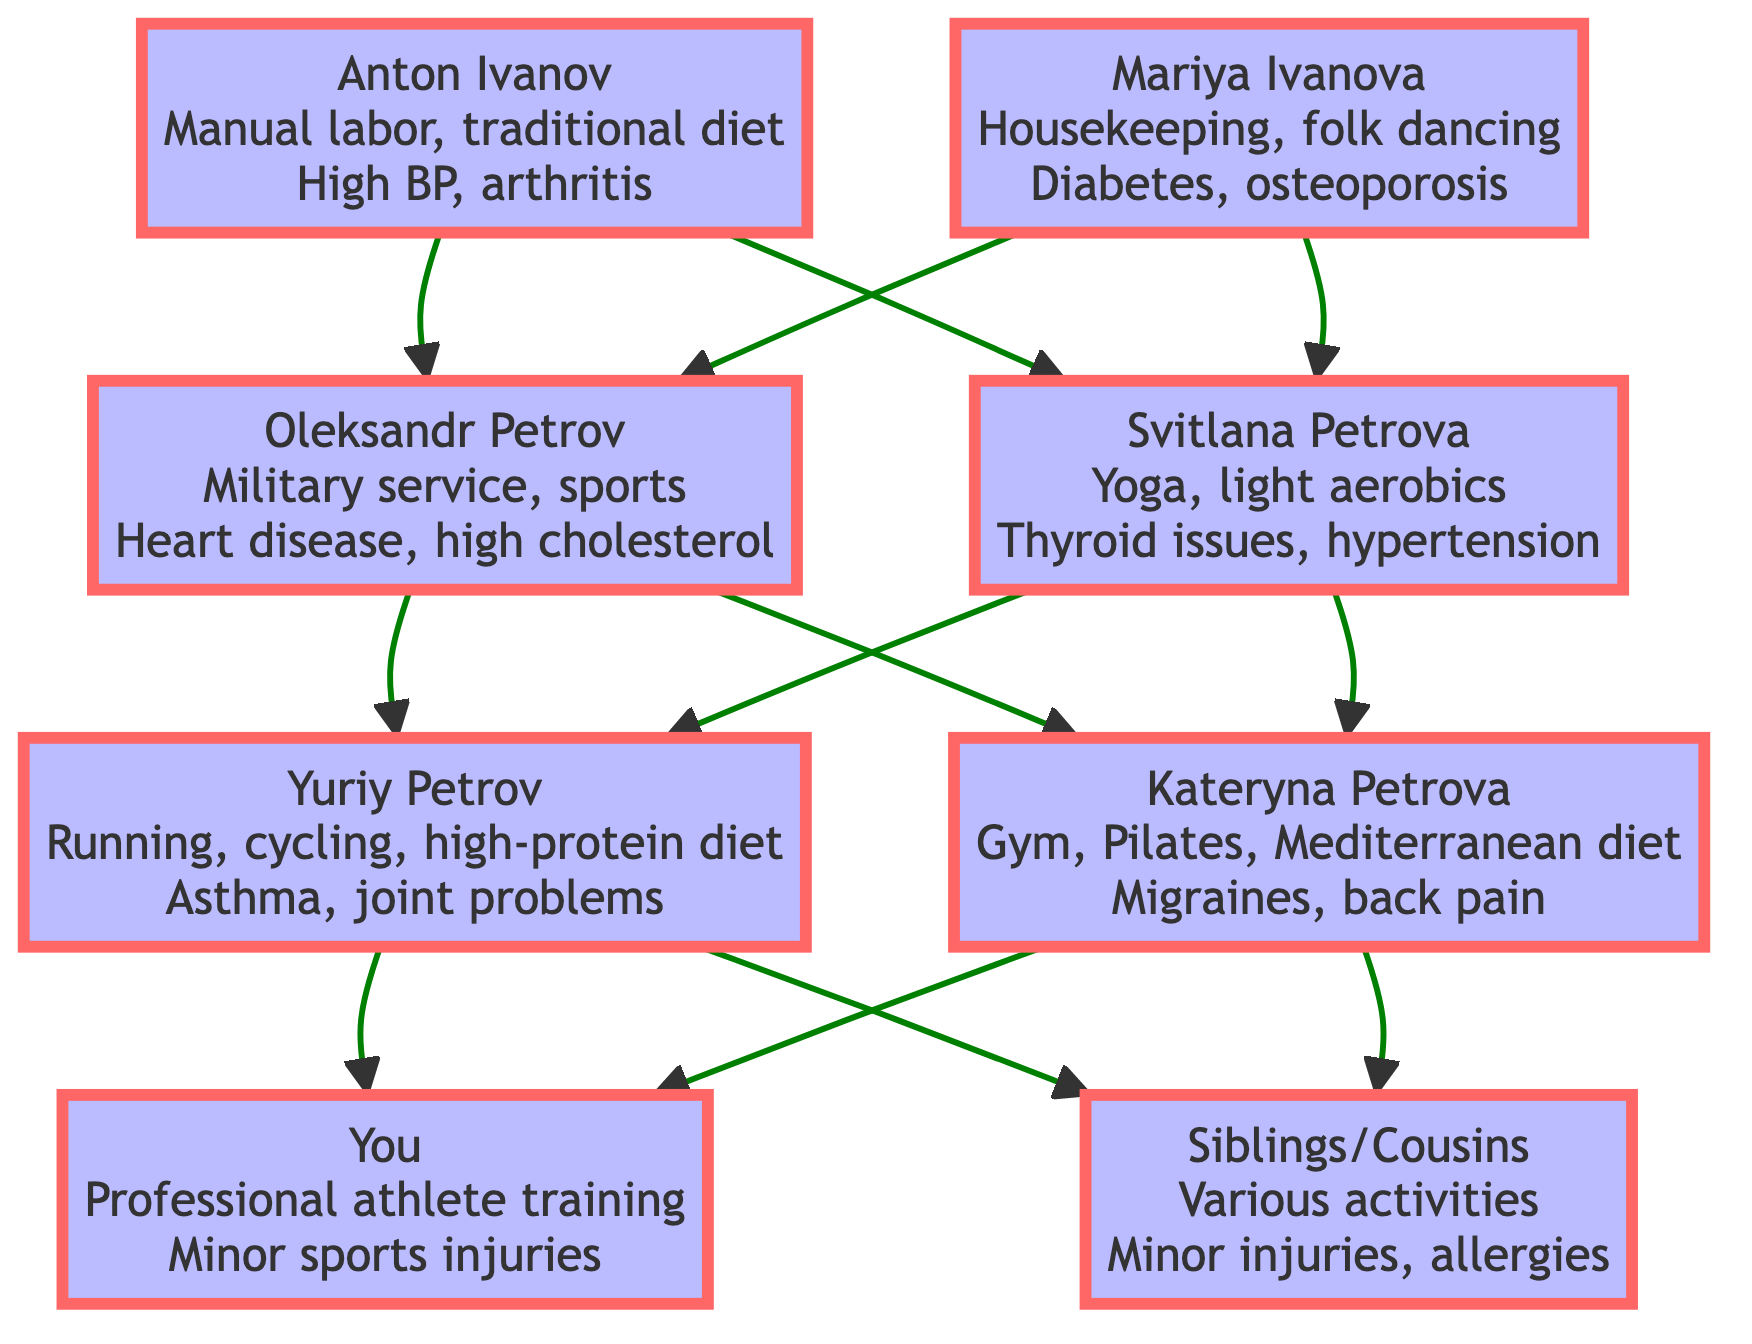What is the health practice of Anton Ivanov? Anton Ivanov's health practice is described as "Manual labor in agriculture, limited formal exercise, traditional Ukrainian diet rich in vegetables and grains." This information can be found directly within the node for Anton Ivanov in the diagram.
Answer: Manual labor in agriculture How many grandparents are represented in the diagram? There are two grandparents shown in the diagram: Oleksandr Petrov and Svitlana Petrova. Counting directly from the grandparents' nodes confirms this.
Answer: 2 Which family member has a health issue with diabetes? The individual with a health issue of diabetes is Mariya Ivanova, as stated in her medical history in the diagram.
Answer: Mariya Ivanova What is the primary health fitness practice of Yuriy Petrov? Yuriy Petrov's primary health fitness practice is detailed as "Running, cycling, high-protein diet, active lifestyle with consistent exercise." This is clearly indicated in Yuriy's node.
Answer: Running, cycling, high-protein diet Which two family members introduced a focus on balanced diets? The two family members that emphasized balanced diets are Yuriy Petrov and Kateryna Petrova. Yuriy focuses on balancing proteins and carbs, while Kateryna promotes a Mediterranean diet rich in vegetables and lean proteins. Their impacts on family diet are noted in their respective nodes.
Answer: Yuriy Petrov and Kateryna Petrova Who has a medical history of heart disease? Oleksandr Petrov has a medical history of heart disease, as indicated in his respective node in the diagram.
Answer: Oleksandr Petrov What is the health practice of your generation (yourself)? My health fitness practice is described as "Professional training for Summer Universiade, daily workouts including cardio and strength training, sports-specific diet with supplements". This information is found under the node for "You".
Answer: Professional training for Summer Universiade Which generation practiced yoga? The generation that practiced yoga is the grandparents' generation, specifically Svitlana Petrova, as stated in her health fitness practices noted in the diagram.
Answer: Grandparents' generation What common health issue is noted in both the great-grandparents' generation? The common health issue noted in both great-grandparents' generation is "high blood pressure", affecting Anton Ivanov, and "diabetes," affecting Mariya Ivanova. This reflects a trend in health issues within that generation.
Answer: High blood pressure, diabetes 